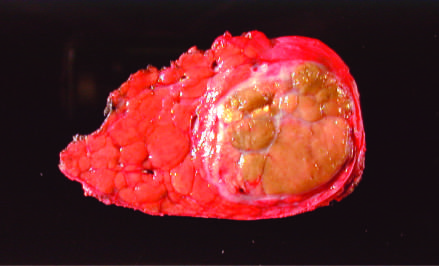what is removed at autopsy showing a unifocal, massive neoplasm replacing most of the right hepatic lobe in a noncirrhotic liver?
Answer the question using a single word or phrase. The liver 